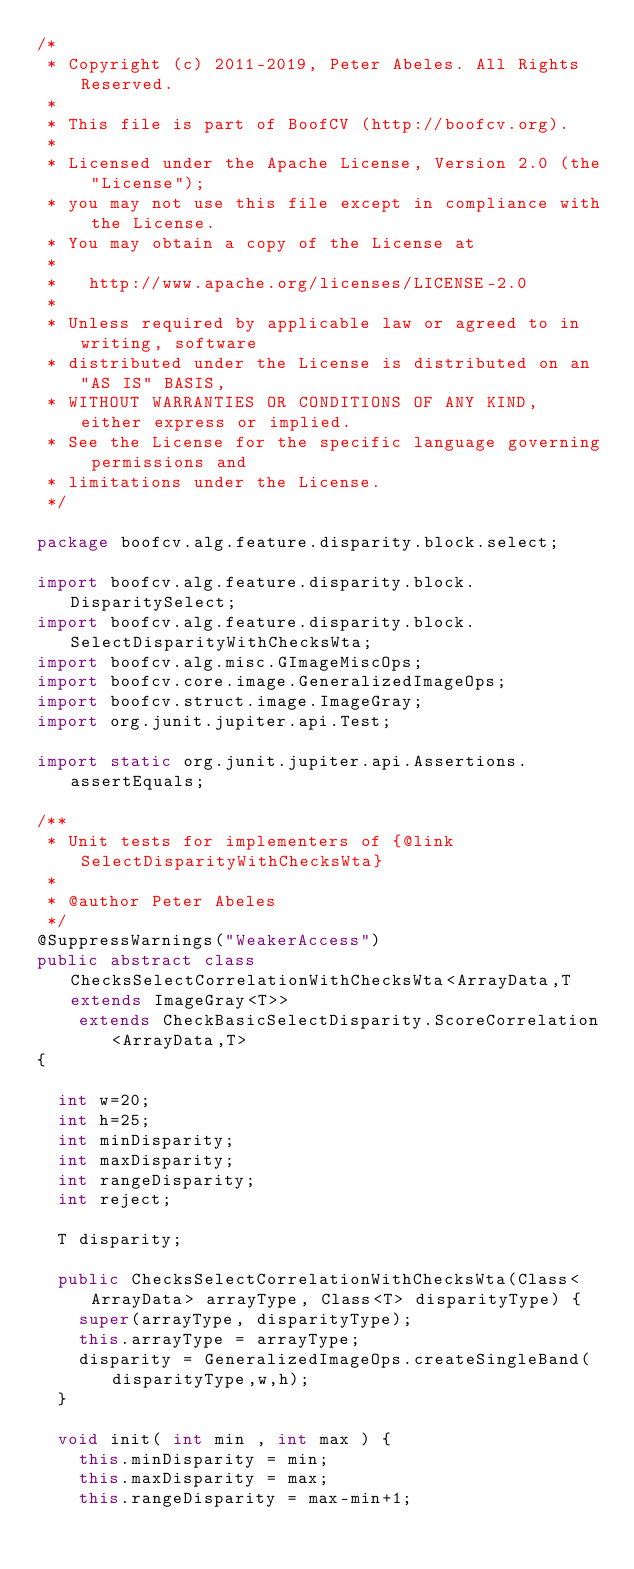<code> <loc_0><loc_0><loc_500><loc_500><_Java_>/*
 * Copyright (c) 2011-2019, Peter Abeles. All Rights Reserved.
 *
 * This file is part of BoofCV (http://boofcv.org).
 *
 * Licensed under the Apache License, Version 2.0 (the "License");
 * you may not use this file except in compliance with the License.
 * You may obtain a copy of the License at
 *
 *   http://www.apache.org/licenses/LICENSE-2.0
 *
 * Unless required by applicable law or agreed to in writing, software
 * distributed under the License is distributed on an "AS IS" BASIS,
 * WITHOUT WARRANTIES OR CONDITIONS OF ANY KIND, either express or implied.
 * See the License for the specific language governing permissions and
 * limitations under the License.
 */

package boofcv.alg.feature.disparity.block.select;

import boofcv.alg.feature.disparity.block.DisparitySelect;
import boofcv.alg.feature.disparity.block.SelectDisparityWithChecksWta;
import boofcv.alg.misc.GImageMiscOps;
import boofcv.core.image.GeneralizedImageOps;
import boofcv.struct.image.ImageGray;
import org.junit.jupiter.api.Test;

import static org.junit.jupiter.api.Assertions.assertEquals;

/**
 * Unit tests for implementers of {@link SelectDisparityWithChecksWta}
 *
 * @author Peter Abeles
 */
@SuppressWarnings("WeakerAccess")
public abstract class ChecksSelectCorrelationWithChecksWta<ArrayData,T extends ImageGray<T>>
		extends CheckBasicSelectDisparity.ScoreCorrelation<ArrayData,T>
{

	int w=20;
	int h=25;
	int minDisparity;
	int maxDisparity;
	int rangeDisparity;
	int reject;

	T disparity;

	public ChecksSelectCorrelationWithChecksWta(Class<ArrayData> arrayType, Class<T> disparityType) {
		super(arrayType, disparityType);
		this.arrayType = arrayType;
		disparity = GeneralizedImageOps.createSingleBand(disparityType,w,h);
	}

	void init( int min , int max ) {
		this.minDisparity = min;
		this.maxDisparity = max;
		this.rangeDisparity = max-min+1;</code> 